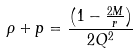Convert formula to latex. <formula><loc_0><loc_0><loc_500><loc_500>\rho + p = \frac { \left ( 1 - \frac { 2 M } { r } \right ) } { 2 Q ^ { 2 } }</formula> 